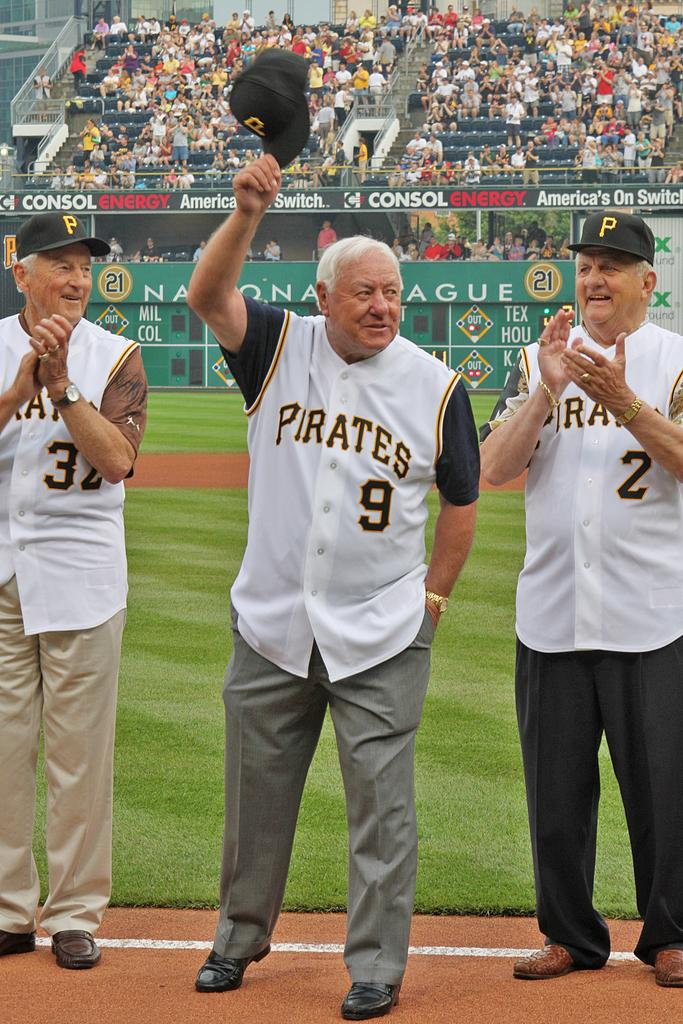<image>
Render a clear and concise summary of the photo. Three old men wear Pirates uniforms while being cheered on in a ballpark. 